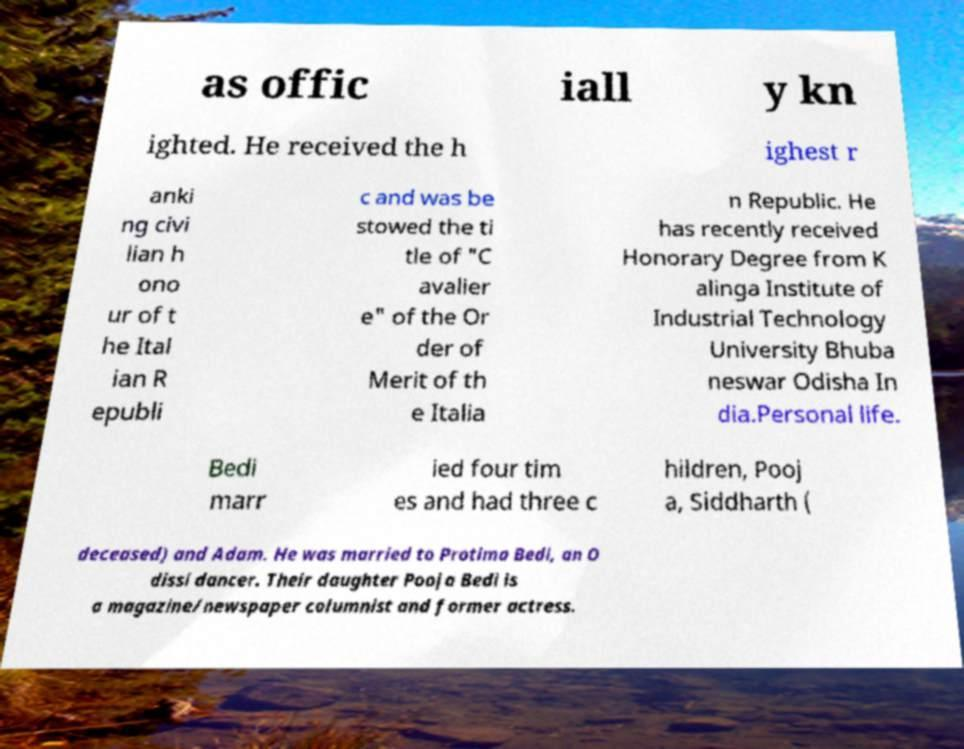Could you extract and type out the text from this image? as offic iall y kn ighted. He received the h ighest r anki ng civi lian h ono ur of t he Ital ian R epubli c and was be stowed the ti tle of "C avalier e" of the Or der of Merit of th e Italia n Republic. He has recently received Honorary Degree from K alinga Institute of Industrial Technology University Bhuba neswar Odisha In dia.Personal life. Bedi marr ied four tim es and had three c hildren, Pooj a, Siddharth ( deceased) and Adam. He was married to Protima Bedi, an O dissi dancer. Their daughter Pooja Bedi is a magazine/newspaper columnist and former actress. 